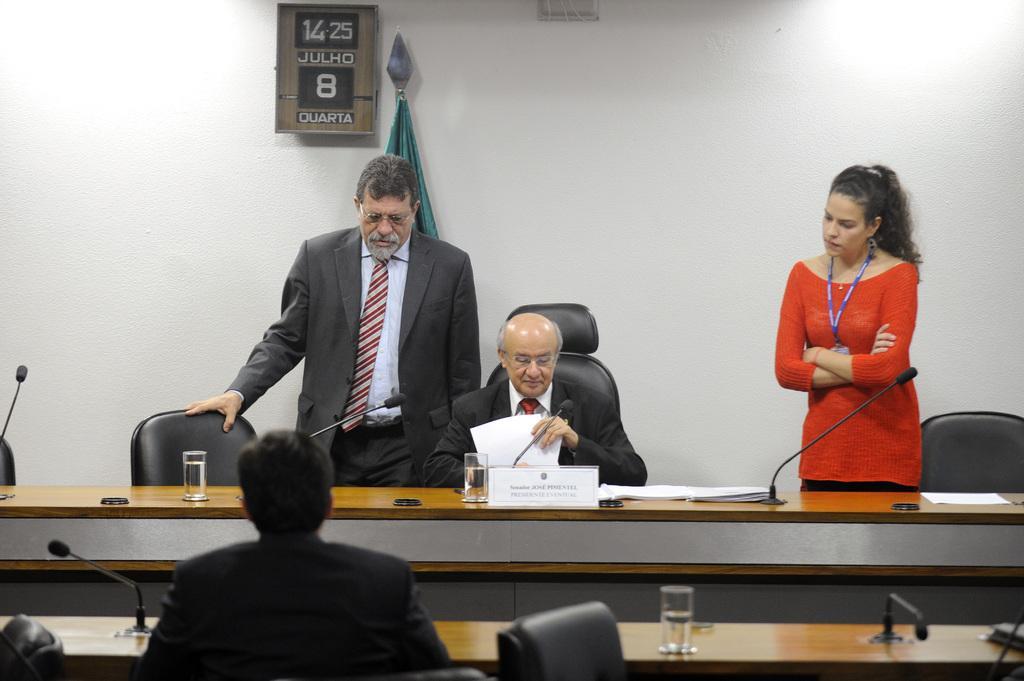In one or two sentences, can you explain what this image depicts? In this image, there are a few people. Among them, we can see a person holding an object. There are a few tables with objects like microphones, glasses with liquid and some posters. We can also see some chairs. We can see the wall with an object. We can also see the pole with some cloth. 